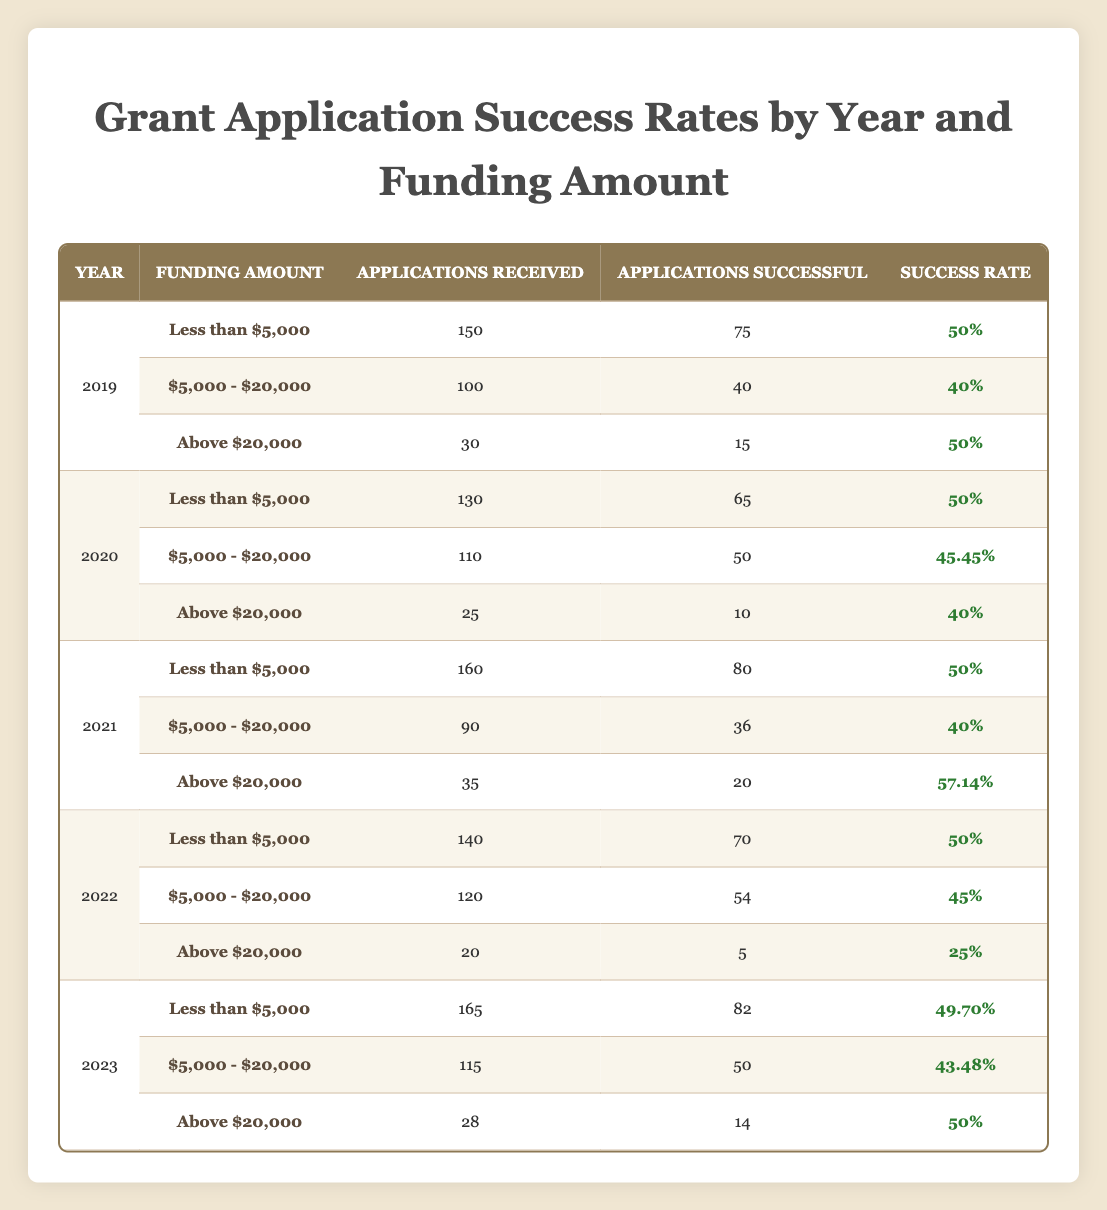What is the success rate for grant applications less than 5,000 in 2021? From the table, we can locate the row for the year 2021 and find the funding amount category "Less than $5,000." The associated success rate is stated as 50%.
Answer: 50% What was the total number of applications received for all funding amounts in 2020? To get the total, we add the applications received from each funding amount in 2020: 130 (Less than $5,000) + 110 ($5,000 to $20,000) + 25 (Above $20,000) = 265.
Answer: 265 Was there a year when the success rate for funding above 20,000 was greater than 50%? By examining the success rates for "Above 20,000," we see that in 2021, the success rate was 57.14%. Thus, it is true that there was a year with a success rate over 50%.
Answer: Yes Which year had the highest success rate for applications with funding between 5,000 and 20,000? Comparing the success rates for the $5,000 to $20,000 category across different years: 40% (2019), 45.45% (2020), 40% (2021), 45% (2022), and 43.48% (2023). The highest is 45.45%, which occurred in 2020.
Answer: 2020 What is the average success rate for funding amount categories in 2022? We need to calculate the average of the success rates from the three funding amount categories in 2022: 50% (Less than $5,000), 45% ($5,000 to $20,000), and 25% (Above $20,000). The sum of these rates is 120%, and dividing by 3 gives us an average of 40%.
Answer: 40% 